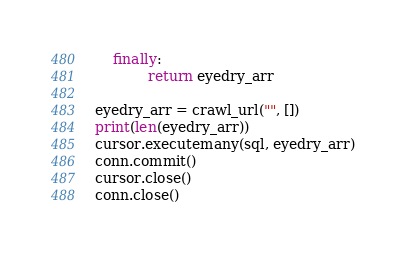<code> <loc_0><loc_0><loc_500><loc_500><_Python_>    finally:
            return eyedry_arr

eyedry_arr = crawl_url("", [])
print(len(eyedry_arr))
cursor.executemany(sql, eyedry_arr)
conn.commit()
cursor.close()
conn.close()
</code> 